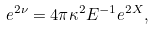<formula> <loc_0><loc_0><loc_500><loc_500>e ^ { 2 \nu } = 4 \pi \kappa ^ { 2 } E ^ { - 1 } e ^ { 2 X } ,</formula> 